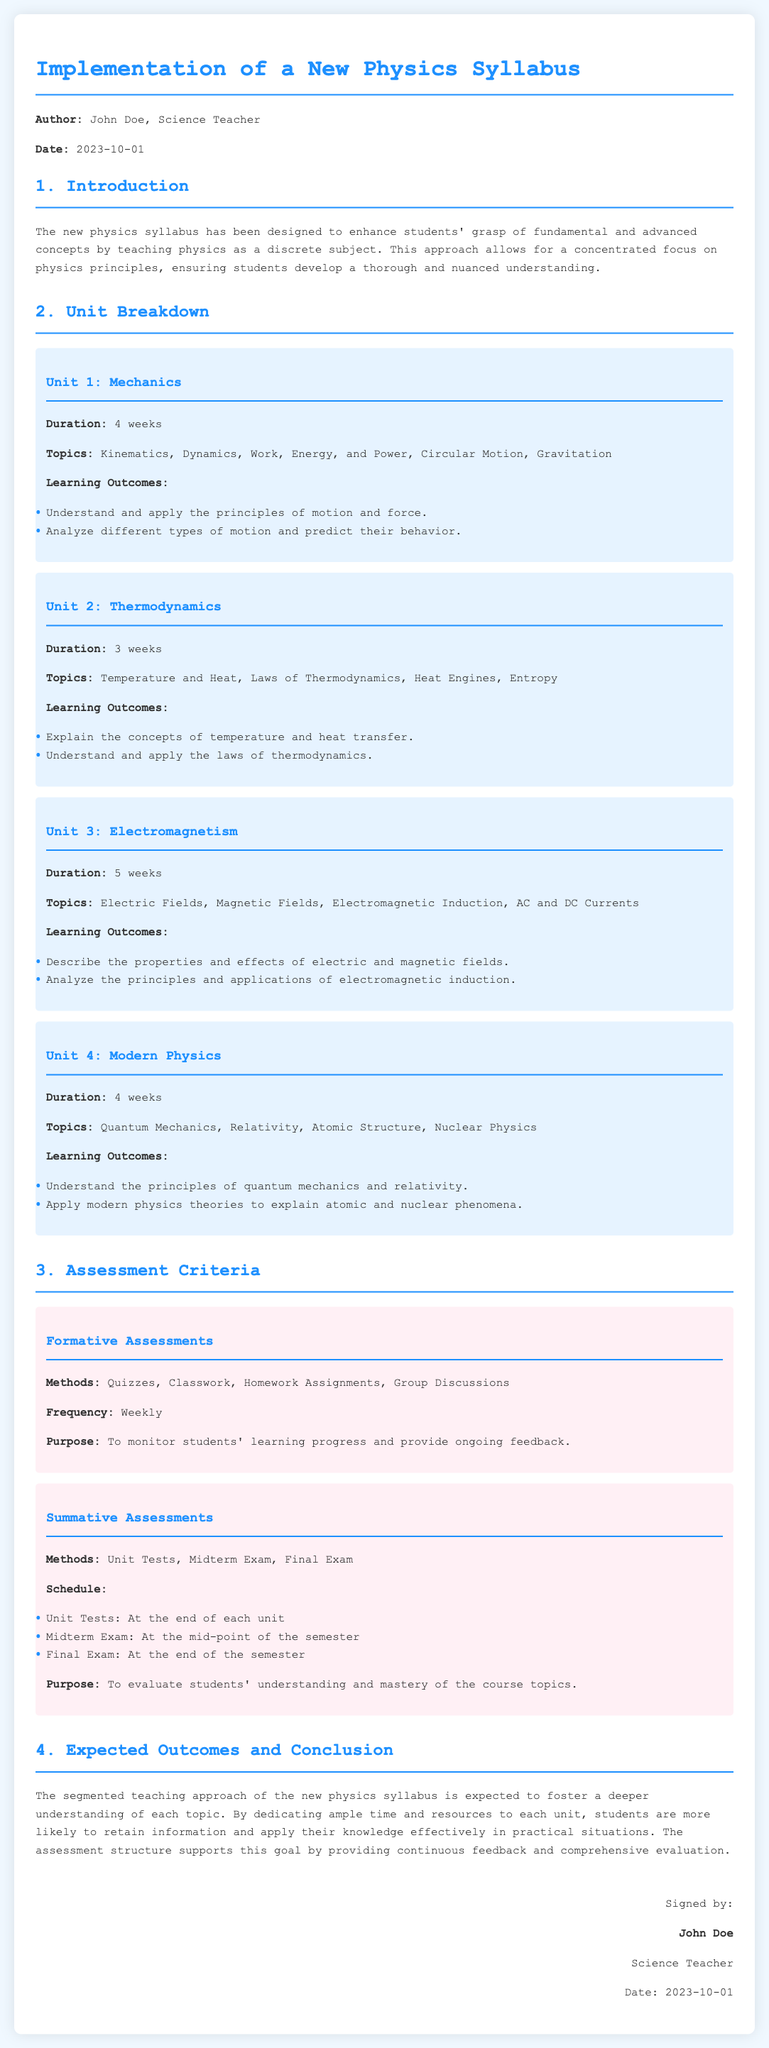What is the author's name? The author's name is provided in the document as John Doe.
Answer: John Doe What is the date of the document? The document specifies the date it was created as 2023-10-01.
Answer: 2023-10-01 How many weeks is Unit 2: Thermodynamics? The document outlines the duration of Unit 2: Thermodynamics as 3 weeks.
Answer: 3 weeks What are the formative assessment methods? The document lists quizzes, classwork, homework assignments, and group discussions as formative assessment methods.
Answer: Quizzes, Classwork, Homework Assignments, Group Discussions How many units are in the syllabus? The document breaks down the syllabus into four distinct units.
Answer: Four What is the main purpose of summative assessments? The document states that the purpose of summative assessments is to evaluate students' understanding and mastery of course topics.
Answer: Evaluate students' understanding and mastery How long is Unit 3: Electromagnetism? The duration for Unit 3: Electromagnetism is outlined as 5 weeks.
Answer: 5 weeks What is the topic covered in Unit 4? The topics covered in Unit 4 include Quantum Mechanics, Relativity, Atomic Structure, and Nuclear Physics.
Answer: Quantum Mechanics, Relativity, Atomic Structure, Nuclear Physics What is the signature role of the author? The document identifies John's role as a Science Teacher.
Answer: Science Teacher 